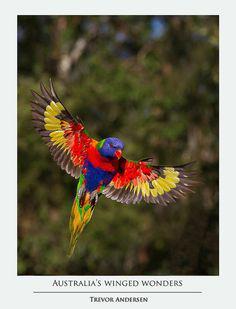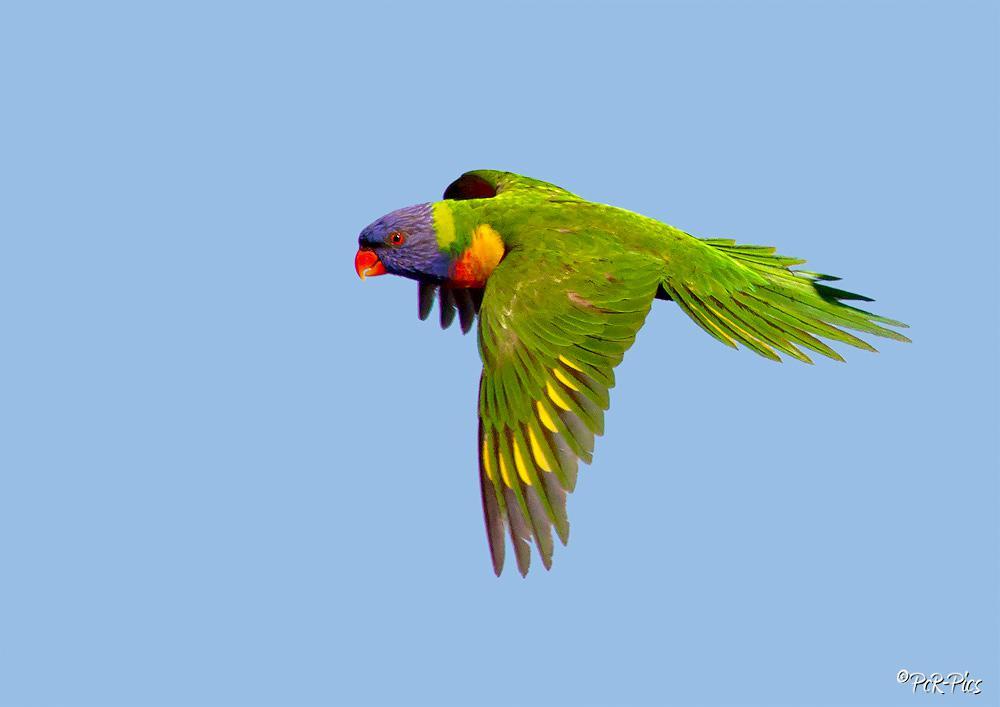The first image is the image on the left, the second image is the image on the right. For the images shown, is this caption "Both images show a parrot that is flying" true? Answer yes or no. Yes. The first image is the image on the left, the second image is the image on the right. For the images displayed, is the sentence "Only parrots in flight are shown in the images." factually correct? Answer yes or no. Yes. 